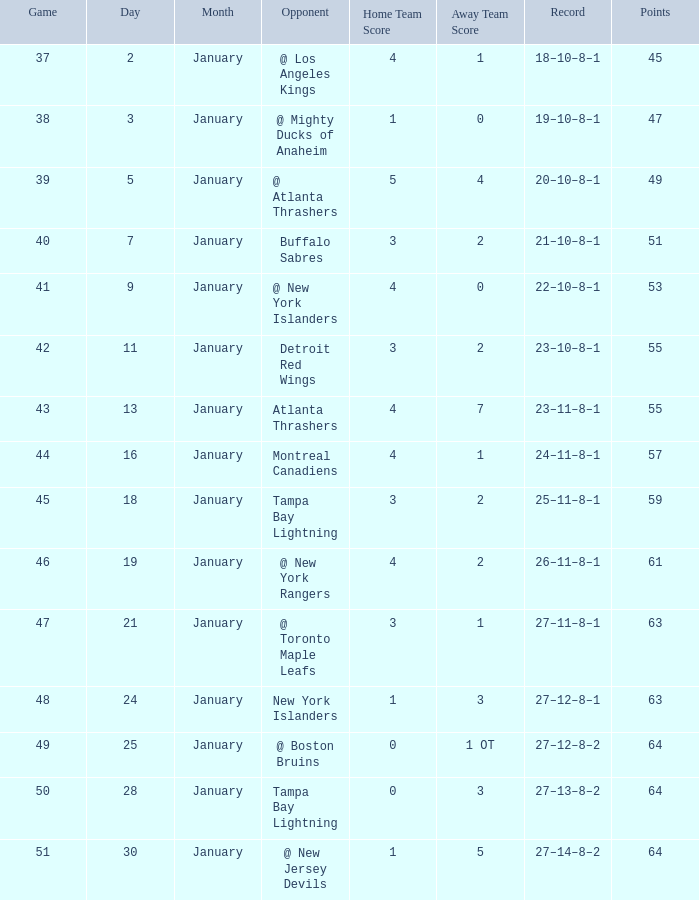Can you parse all the data within this table? {'header': ['Game', 'Day', 'Month', 'Opponent', 'Home Team Score', 'Away Team Score', 'Record', 'Points'], 'rows': [['37', '2', 'January', '@ Los Angeles Kings', '4', '1', '18–10–8–1', '45'], ['38', '3', 'January', '@ Mighty Ducks of Anaheim', '1', '0', '19–10–8–1', '47'], ['39', '5', 'January', '@ Atlanta Thrashers', '5', '4', '20–10–8–1', '49'], ['40', '7', 'January', 'Buffalo Sabres', '3', '2', '21–10–8–1', '51'], ['41', '9', 'January', '@ New York Islanders', '4', '0', '22–10–8–1', '53'], ['42', '11', 'January', 'Detroit Red Wings', '3', '2', '23–10–8–1', '55'], ['43', '13', 'January', 'Atlanta Thrashers', '4', '7', '23–11–8–1', '55'], ['44', '16', 'January', 'Montreal Canadiens', '4', '1', '24–11–8–1', '57'], ['45', '18', 'January', 'Tampa Bay Lightning', '3', '2', '25–11–8–1', '59'], ['46', '19', 'January', '@ New York Rangers', '4', '2', '26–11–8–1', '61'], ['47', '21', 'January', '@ Toronto Maple Leafs', '3', '1', '27–11–8–1', '63'], ['48', '24', 'January', 'New York Islanders', '1', '3', '27–12–8–1', '63'], ['49', '25', 'January', '@ Boston Bruins', '0', '1 OT', '27–12–8–2', '64'], ['50', '28', 'January', 'Tampa Bay Lightning', '0', '3', '27–13–8–2', '64'], ['51', '30', 'January', '@ New Jersey Devils', '1', '5', '27–14–8–2', '64']]} Which Score has Points of 64, and a Game of 49? 0–1 OT. 